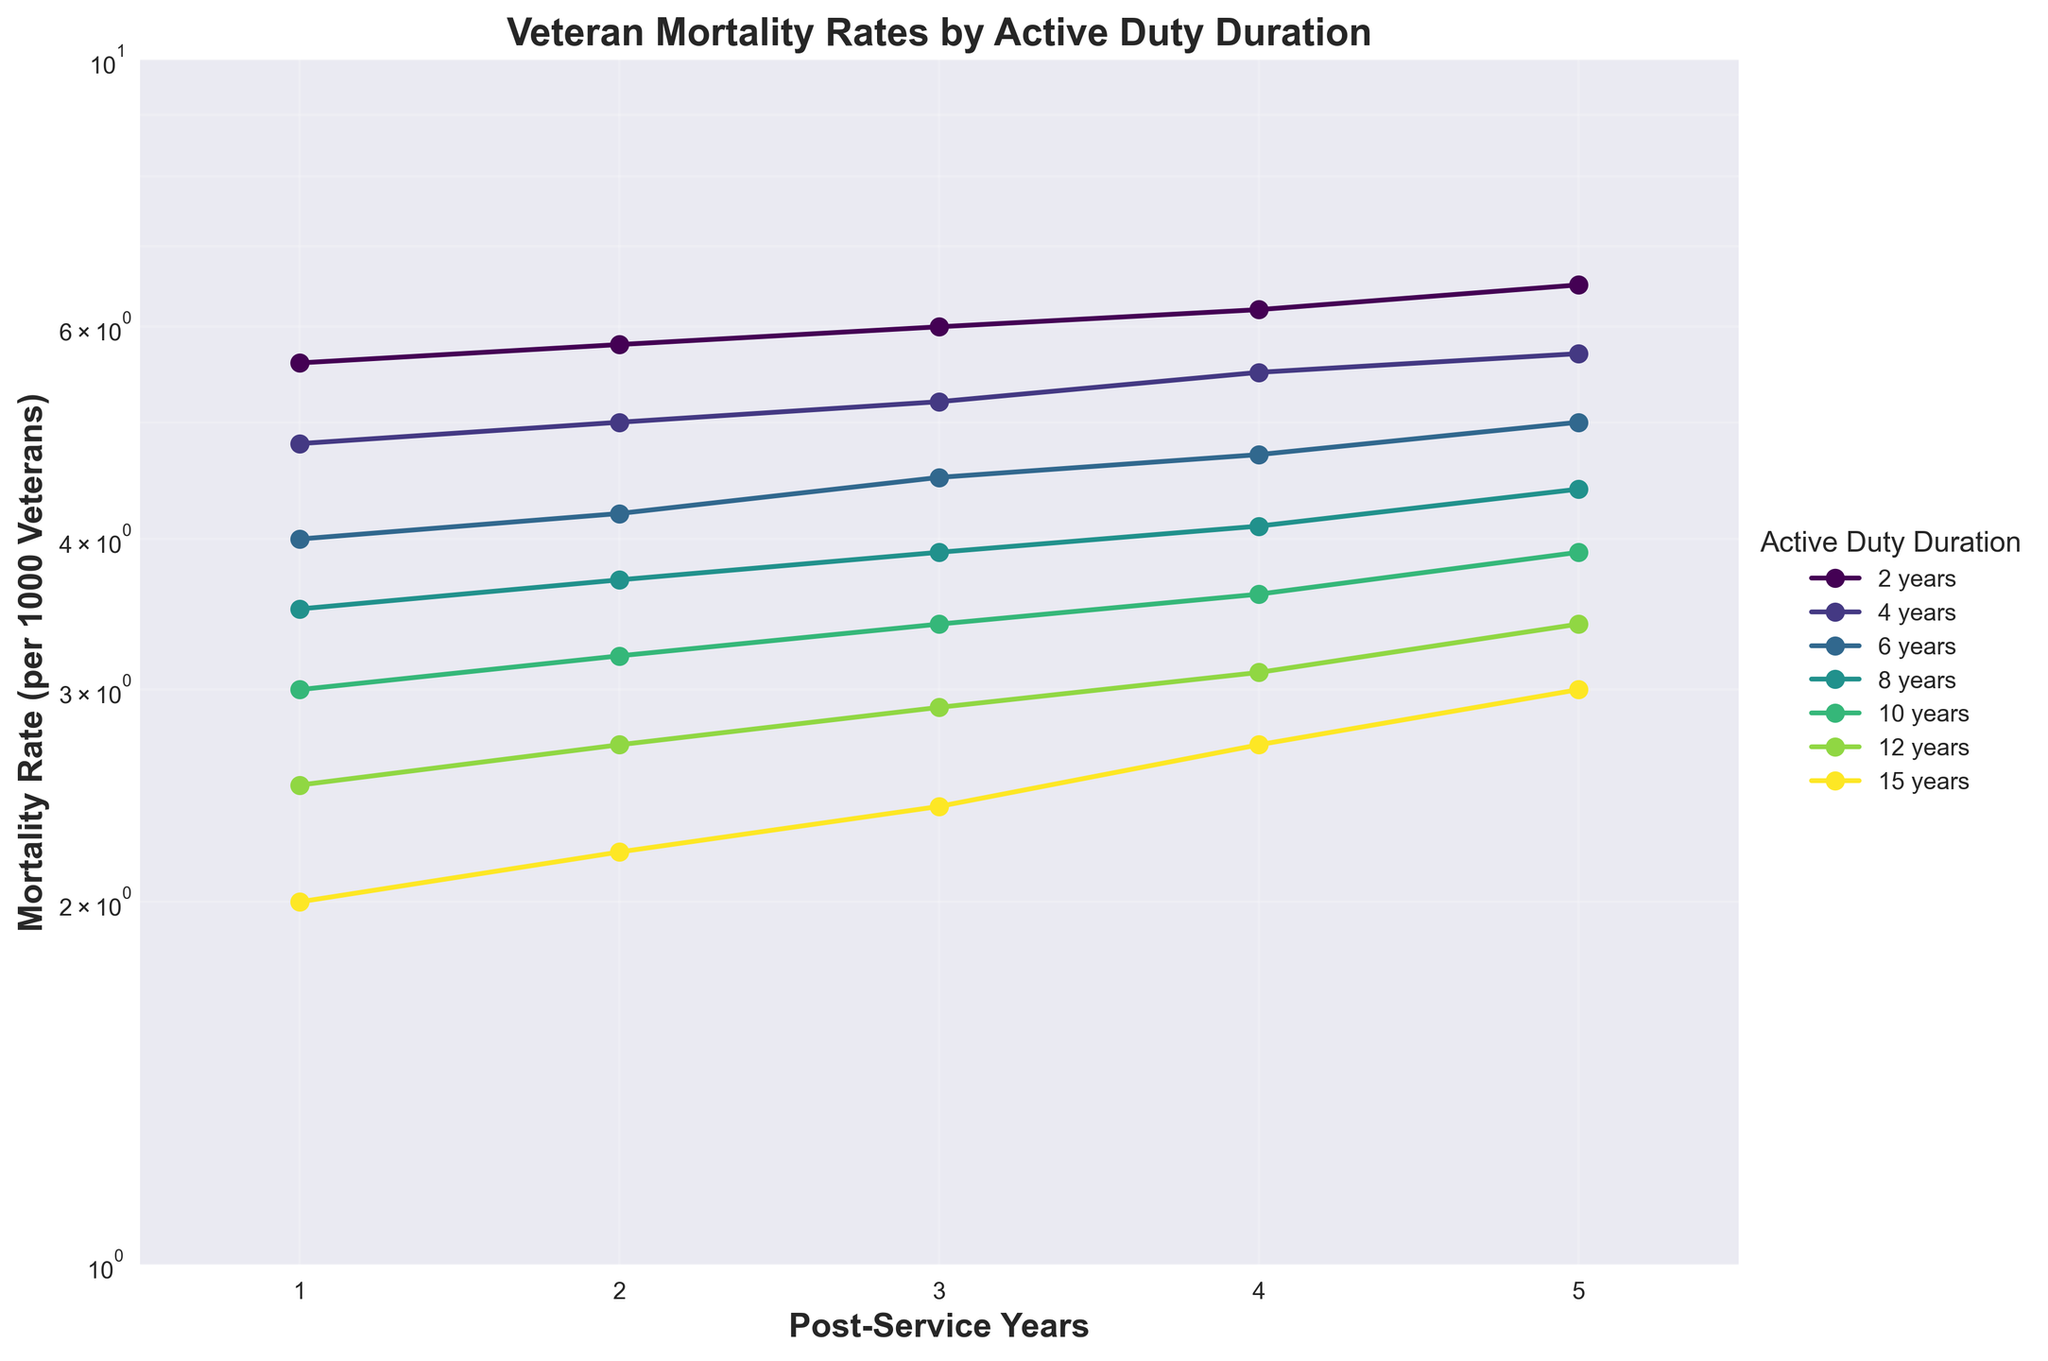What's the title of the figure? The title of the figure is mentioned on top of the plot. It describes the main insight provided by the figure.
Answer: Veteran Mortality Rates by Active Duty Duration How many different durations of active duty service are represented in the plot? Each unique color and label in the legend represent a different active duty duration. By counting these, we can determine the number of different durations.
Answer: 6 What is the y-axis scale and its range in the plot? The y-axis scale and range can be determined by looking at the axis labels and ticks. The label indicates the type of scale, and the ticks mark the range.
Answer: Log scale, 1 to 10 Which active duty duration has the lowest mortality rate at 5 years post-service? The lowest line at the 5-year mark near '3.0' on the y-axis will indicate the lowest mortality rate. Examine the legend to match the line color to the active duty duration.
Answer: 15 years What is the mortality rate for veterans with 8 years of active duty service after 2 years of post-service? Locate the line for the 8-year duration in the legend, then find the corresponding point at 2 years post-service on the x-axis and read its y-axis value.
Answer: 3.7 How does the mortality rate change from 1 year to 5 years post-service for veterans with 4 years of active duty? Follow the line for 4 years of service from the 1-year to the 5-year mark on the x-axis, and note the change in y-axis values.
Answer: It increases from 4.8 to 5.7 Which active duty duration shows the steepest increase in mortality rate over the 5 post-service years? Determine the slope of each line by comparing changes in mortality rate from 1 to 5 years post-service. The steepest slope indicates the greatest increase.
Answer: 2 years By how much does the mortality rate for 10 years of active duty service change from 3 to 4 years post-service? Identify the line for 10 years of service in the legend, find the points at 3 and 4 years on the x-axis, and calculate the difference in y-axis values.
Answer: 0.2 Compare the mortality rate trends for veterans with 6 years of active duty service and those with 12 years. Who has a lower rate overall? Compare the positions of the lines for 6 years and 12 years of service at multiple points on the x-axis. Overall observation will show which line is consistently lower.
Answer: 12 years 